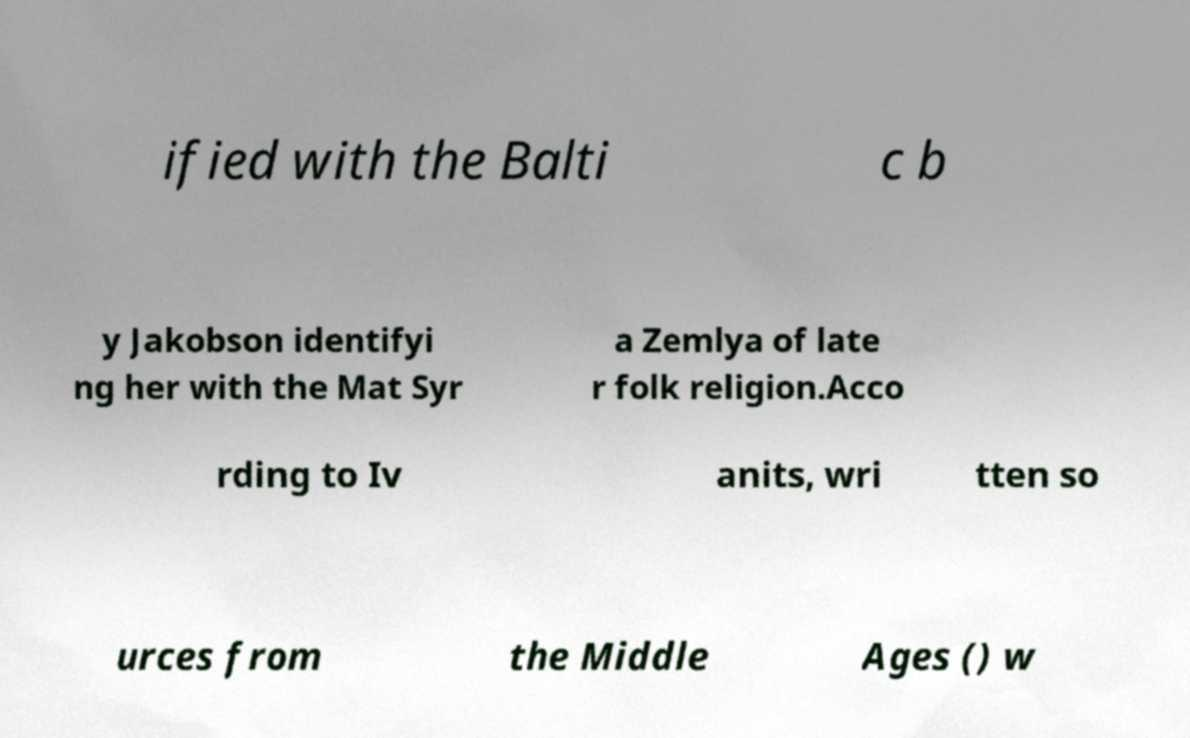Could you assist in decoding the text presented in this image and type it out clearly? ified with the Balti c b y Jakobson identifyi ng her with the Mat Syr a Zemlya of late r folk religion.Acco rding to Iv anits, wri tten so urces from the Middle Ages () w 